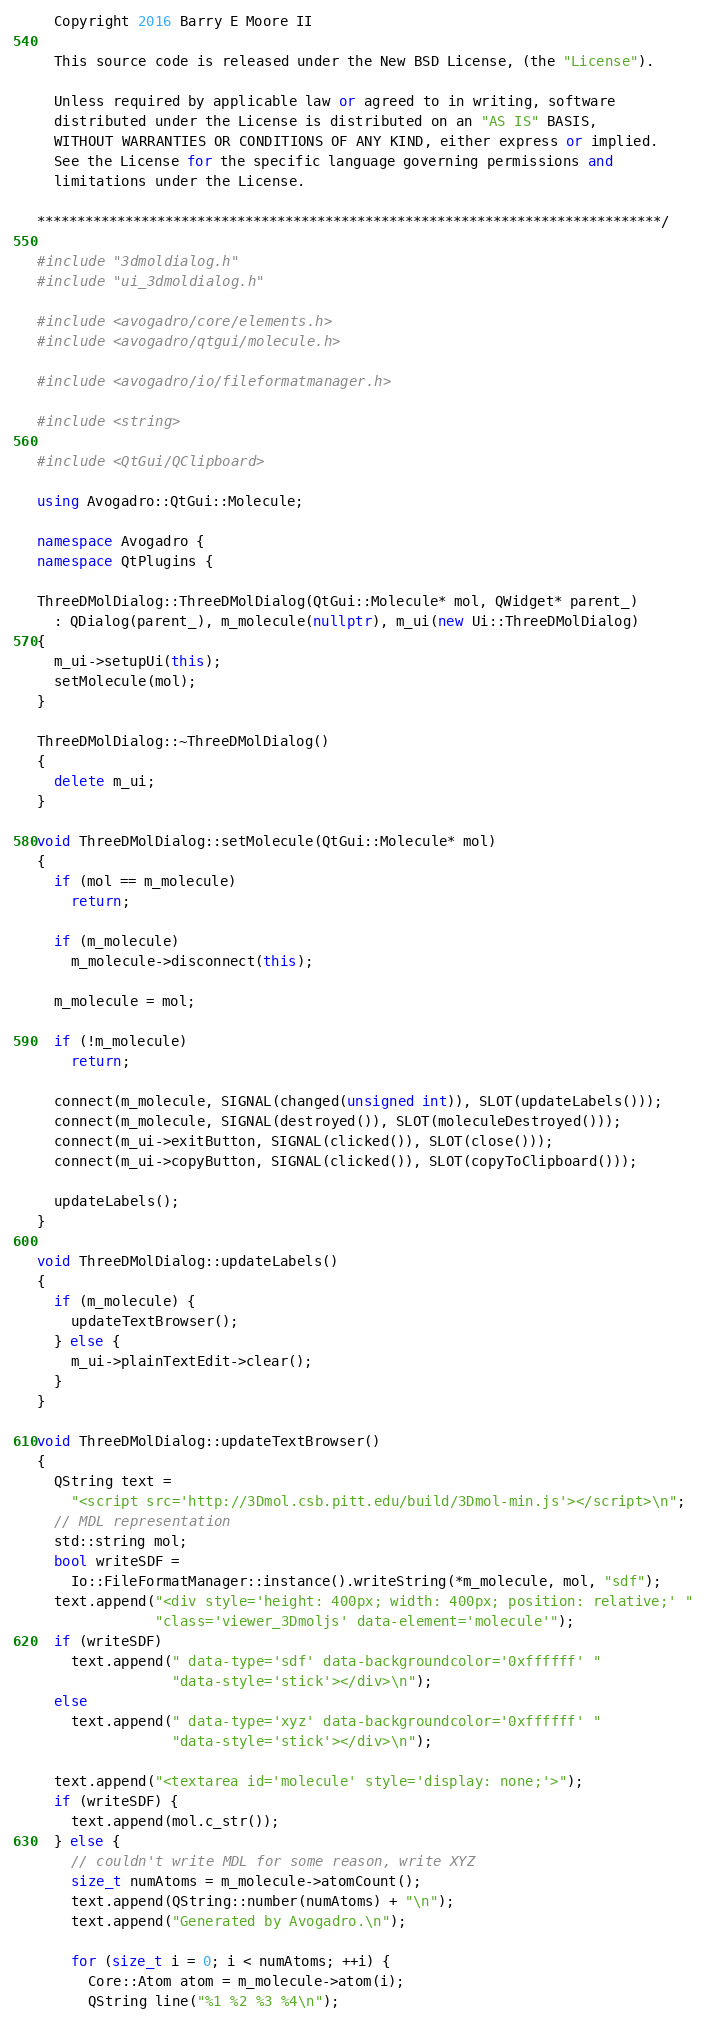<code> <loc_0><loc_0><loc_500><loc_500><_C++_>
  Copyright 2016 Barry E Moore II

  This source code is released under the New BSD License, (the "License").

  Unless required by applicable law or agreed to in writing, software
  distributed under the License is distributed on an "AS IS" BASIS,
  WITHOUT WARRANTIES OR CONDITIONS OF ANY KIND, either express or implied.
  See the License for the specific language governing permissions and
  limitations under the License.

******************************************************************************/

#include "3dmoldialog.h"
#include "ui_3dmoldialog.h"

#include <avogadro/core/elements.h>
#include <avogadro/qtgui/molecule.h>

#include <avogadro/io/fileformatmanager.h>

#include <string>

#include <QtGui/QClipboard>

using Avogadro::QtGui::Molecule;

namespace Avogadro {
namespace QtPlugins {

ThreeDMolDialog::ThreeDMolDialog(QtGui::Molecule* mol, QWidget* parent_)
  : QDialog(parent_), m_molecule(nullptr), m_ui(new Ui::ThreeDMolDialog)
{
  m_ui->setupUi(this);
  setMolecule(mol);
}

ThreeDMolDialog::~ThreeDMolDialog()
{
  delete m_ui;
}

void ThreeDMolDialog::setMolecule(QtGui::Molecule* mol)
{
  if (mol == m_molecule)
    return;

  if (m_molecule)
    m_molecule->disconnect(this);

  m_molecule = mol;

  if (!m_molecule)
    return;

  connect(m_molecule, SIGNAL(changed(unsigned int)), SLOT(updateLabels()));
  connect(m_molecule, SIGNAL(destroyed()), SLOT(moleculeDestroyed()));
  connect(m_ui->exitButton, SIGNAL(clicked()), SLOT(close()));
  connect(m_ui->copyButton, SIGNAL(clicked()), SLOT(copyToClipboard()));

  updateLabels();
}

void ThreeDMolDialog::updateLabels()
{
  if (m_molecule) {
    updateTextBrowser();
  } else {
    m_ui->plainTextEdit->clear();
  }
}

void ThreeDMolDialog::updateTextBrowser()
{
  QString text =
    "<script src='http://3Dmol.csb.pitt.edu/build/3Dmol-min.js'></script>\n";
  // MDL representation
  std::string mol;
  bool writeSDF =
    Io::FileFormatManager::instance().writeString(*m_molecule, mol, "sdf");
  text.append("<div style='height: 400px; width: 400px; position: relative;' "
              "class='viewer_3Dmoljs' data-element='molecule'");
  if (writeSDF)
    text.append(" data-type='sdf' data-backgroundcolor='0xffffff' "
                "data-style='stick'></div>\n");
  else
    text.append(" data-type='xyz' data-backgroundcolor='0xffffff' "
                "data-style='stick'></div>\n");

  text.append("<textarea id='molecule' style='display: none;'>");
  if (writeSDF) {
    text.append(mol.c_str());
  } else {
    // couldn't write MDL for some reason, write XYZ
    size_t numAtoms = m_molecule->atomCount();
    text.append(QString::number(numAtoms) + "\n");
    text.append("Generated by Avogadro.\n");

    for (size_t i = 0; i < numAtoms; ++i) {
      Core::Atom atom = m_molecule->atom(i);
      QString line("%1 %2 %3 %4\n");</code> 